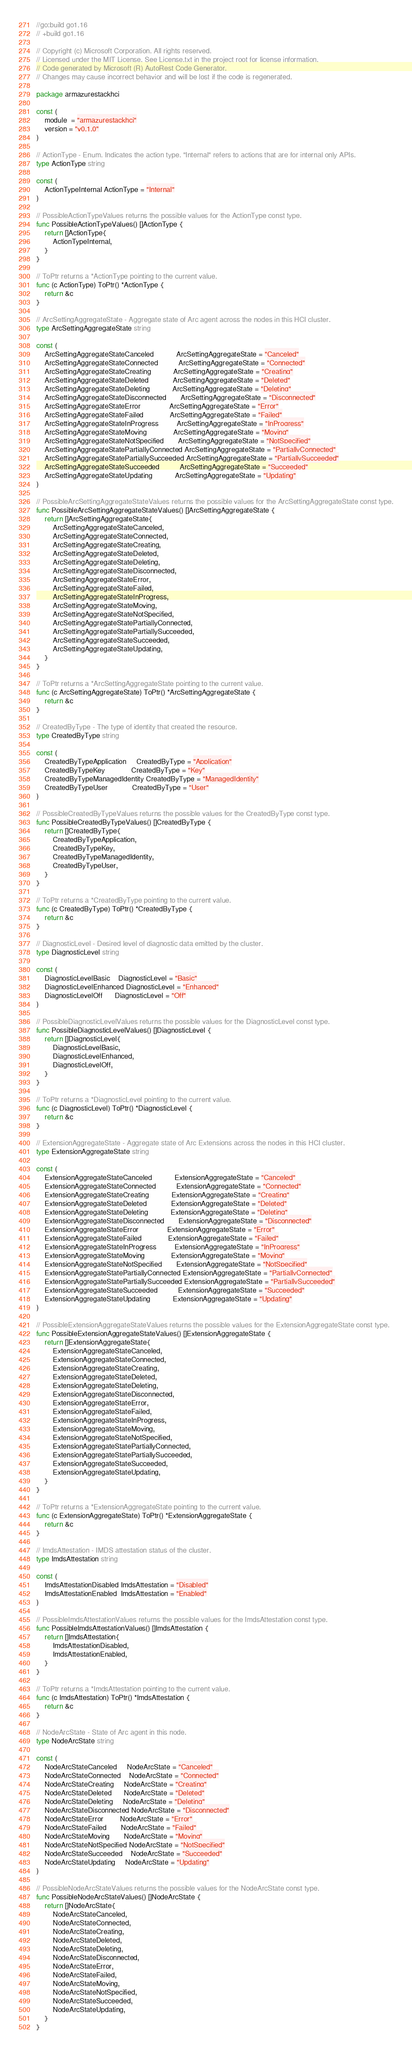<code> <loc_0><loc_0><loc_500><loc_500><_Go_>//go:build go1.16
// +build go1.16

// Copyright (c) Microsoft Corporation. All rights reserved.
// Licensed under the MIT License. See License.txt in the project root for license information.
// Code generated by Microsoft (R) AutoRest Code Generator.
// Changes may cause incorrect behavior and will be lost if the code is regenerated.

package armazurestackhci

const (
	module  = "armazurestackhci"
	version = "v0.1.0"
)

// ActionType - Enum. Indicates the action type. "Internal" refers to actions that are for internal only APIs.
type ActionType string

const (
	ActionTypeInternal ActionType = "Internal"
)

// PossibleActionTypeValues returns the possible values for the ActionType const type.
func PossibleActionTypeValues() []ActionType {
	return []ActionType{
		ActionTypeInternal,
	}
}

// ToPtr returns a *ActionType pointing to the current value.
func (c ActionType) ToPtr() *ActionType {
	return &c
}

// ArcSettingAggregateState - Aggregate state of Arc agent across the nodes in this HCI cluster.
type ArcSettingAggregateState string

const (
	ArcSettingAggregateStateCanceled           ArcSettingAggregateState = "Canceled"
	ArcSettingAggregateStateConnected          ArcSettingAggregateState = "Connected"
	ArcSettingAggregateStateCreating           ArcSettingAggregateState = "Creating"
	ArcSettingAggregateStateDeleted            ArcSettingAggregateState = "Deleted"
	ArcSettingAggregateStateDeleting           ArcSettingAggregateState = "Deleting"
	ArcSettingAggregateStateDisconnected       ArcSettingAggregateState = "Disconnected"
	ArcSettingAggregateStateError              ArcSettingAggregateState = "Error"
	ArcSettingAggregateStateFailed             ArcSettingAggregateState = "Failed"
	ArcSettingAggregateStateInProgress         ArcSettingAggregateState = "InProgress"
	ArcSettingAggregateStateMoving             ArcSettingAggregateState = "Moving"
	ArcSettingAggregateStateNotSpecified       ArcSettingAggregateState = "NotSpecified"
	ArcSettingAggregateStatePartiallyConnected ArcSettingAggregateState = "PartiallyConnected"
	ArcSettingAggregateStatePartiallySucceeded ArcSettingAggregateState = "PartiallySucceeded"
	ArcSettingAggregateStateSucceeded          ArcSettingAggregateState = "Succeeded"
	ArcSettingAggregateStateUpdating           ArcSettingAggregateState = "Updating"
)

// PossibleArcSettingAggregateStateValues returns the possible values for the ArcSettingAggregateState const type.
func PossibleArcSettingAggregateStateValues() []ArcSettingAggregateState {
	return []ArcSettingAggregateState{
		ArcSettingAggregateStateCanceled,
		ArcSettingAggregateStateConnected,
		ArcSettingAggregateStateCreating,
		ArcSettingAggregateStateDeleted,
		ArcSettingAggregateStateDeleting,
		ArcSettingAggregateStateDisconnected,
		ArcSettingAggregateStateError,
		ArcSettingAggregateStateFailed,
		ArcSettingAggregateStateInProgress,
		ArcSettingAggregateStateMoving,
		ArcSettingAggregateStateNotSpecified,
		ArcSettingAggregateStatePartiallyConnected,
		ArcSettingAggregateStatePartiallySucceeded,
		ArcSettingAggregateStateSucceeded,
		ArcSettingAggregateStateUpdating,
	}
}

// ToPtr returns a *ArcSettingAggregateState pointing to the current value.
func (c ArcSettingAggregateState) ToPtr() *ArcSettingAggregateState {
	return &c
}

// CreatedByType - The type of identity that created the resource.
type CreatedByType string

const (
	CreatedByTypeApplication     CreatedByType = "Application"
	CreatedByTypeKey             CreatedByType = "Key"
	CreatedByTypeManagedIdentity CreatedByType = "ManagedIdentity"
	CreatedByTypeUser            CreatedByType = "User"
)

// PossibleCreatedByTypeValues returns the possible values for the CreatedByType const type.
func PossibleCreatedByTypeValues() []CreatedByType {
	return []CreatedByType{
		CreatedByTypeApplication,
		CreatedByTypeKey,
		CreatedByTypeManagedIdentity,
		CreatedByTypeUser,
	}
}

// ToPtr returns a *CreatedByType pointing to the current value.
func (c CreatedByType) ToPtr() *CreatedByType {
	return &c
}

// DiagnosticLevel - Desired level of diagnostic data emitted by the cluster.
type DiagnosticLevel string

const (
	DiagnosticLevelBasic    DiagnosticLevel = "Basic"
	DiagnosticLevelEnhanced DiagnosticLevel = "Enhanced"
	DiagnosticLevelOff      DiagnosticLevel = "Off"
)

// PossibleDiagnosticLevelValues returns the possible values for the DiagnosticLevel const type.
func PossibleDiagnosticLevelValues() []DiagnosticLevel {
	return []DiagnosticLevel{
		DiagnosticLevelBasic,
		DiagnosticLevelEnhanced,
		DiagnosticLevelOff,
	}
}

// ToPtr returns a *DiagnosticLevel pointing to the current value.
func (c DiagnosticLevel) ToPtr() *DiagnosticLevel {
	return &c
}

// ExtensionAggregateState - Aggregate state of Arc Extensions across the nodes in this HCI cluster.
type ExtensionAggregateState string

const (
	ExtensionAggregateStateCanceled           ExtensionAggregateState = "Canceled"
	ExtensionAggregateStateConnected          ExtensionAggregateState = "Connected"
	ExtensionAggregateStateCreating           ExtensionAggregateState = "Creating"
	ExtensionAggregateStateDeleted            ExtensionAggregateState = "Deleted"
	ExtensionAggregateStateDeleting           ExtensionAggregateState = "Deleting"
	ExtensionAggregateStateDisconnected       ExtensionAggregateState = "Disconnected"
	ExtensionAggregateStateError              ExtensionAggregateState = "Error"
	ExtensionAggregateStateFailed             ExtensionAggregateState = "Failed"
	ExtensionAggregateStateInProgress         ExtensionAggregateState = "InProgress"
	ExtensionAggregateStateMoving             ExtensionAggregateState = "Moving"
	ExtensionAggregateStateNotSpecified       ExtensionAggregateState = "NotSpecified"
	ExtensionAggregateStatePartiallyConnected ExtensionAggregateState = "PartiallyConnected"
	ExtensionAggregateStatePartiallySucceeded ExtensionAggregateState = "PartiallySucceeded"
	ExtensionAggregateStateSucceeded          ExtensionAggregateState = "Succeeded"
	ExtensionAggregateStateUpdating           ExtensionAggregateState = "Updating"
)

// PossibleExtensionAggregateStateValues returns the possible values for the ExtensionAggregateState const type.
func PossibleExtensionAggregateStateValues() []ExtensionAggregateState {
	return []ExtensionAggregateState{
		ExtensionAggregateStateCanceled,
		ExtensionAggregateStateConnected,
		ExtensionAggregateStateCreating,
		ExtensionAggregateStateDeleted,
		ExtensionAggregateStateDeleting,
		ExtensionAggregateStateDisconnected,
		ExtensionAggregateStateError,
		ExtensionAggregateStateFailed,
		ExtensionAggregateStateInProgress,
		ExtensionAggregateStateMoving,
		ExtensionAggregateStateNotSpecified,
		ExtensionAggregateStatePartiallyConnected,
		ExtensionAggregateStatePartiallySucceeded,
		ExtensionAggregateStateSucceeded,
		ExtensionAggregateStateUpdating,
	}
}

// ToPtr returns a *ExtensionAggregateState pointing to the current value.
func (c ExtensionAggregateState) ToPtr() *ExtensionAggregateState {
	return &c
}

// ImdsAttestation - IMDS attestation status of the cluster.
type ImdsAttestation string

const (
	ImdsAttestationDisabled ImdsAttestation = "Disabled"
	ImdsAttestationEnabled  ImdsAttestation = "Enabled"
)

// PossibleImdsAttestationValues returns the possible values for the ImdsAttestation const type.
func PossibleImdsAttestationValues() []ImdsAttestation {
	return []ImdsAttestation{
		ImdsAttestationDisabled,
		ImdsAttestationEnabled,
	}
}

// ToPtr returns a *ImdsAttestation pointing to the current value.
func (c ImdsAttestation) ToPtr() *ImdsAttestation {
	return &c
}

// NodeArcState - State of Arc agent in this node.
type NodeArcState string

const (
	NodeArcStateCanceled     NodeArcState = "Canceled"
	NodeArcStateConnected    NodeArcState = "Connected"
	NodeArcStateCreating     NodeArcState = "Creating"
	NodeArcStateDeleted      NodeArcState = "Deleted"
	NodeArcStateDeleting     NodeArcState = "Deleting"
	NodeArcStateDisconnected NodeArcState = "Disconnected"
	NodeArcStateError        NodeArcState = "Error"
	NodeArcStateFailed       NodeArcState = "Failed"
	NodeArcStateMoving       NodeArcState = "Moving"
	NodeArcStateNotSpecified NodeArcState = "NotSpecified"
	NodeArcStateSucceeded    NodeArcState = "Succeeded"
	NodeArcStateUpdating     NodeArcState = "Updating"
)

// PossibleNodeArcStateValues returns the possible values for the NodeArcState const type.
func PossibleNodeArcStateValues() []NodeArcState {
	return []NodeArcState{
		NodeArcStateCanceled,
		NodeArcStateConnected,
		NodeArcStateCreating,
		NodeArcStateDeleted,
		NodeArcStateDeleting,
		NodeArcStateDisconnected,
		NodeArcStateError,
		NodeArcStateFailed,
		NodeArcStateMoving,
		NodeArcStateNotSpecified,
		NodeArcStateSucceeded,
		NodeArcStateUpdating,
	}
}
</code> 